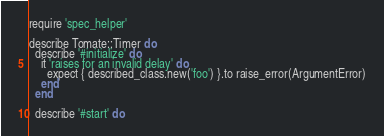Convert code to text. <code><loc_0><loc_0><loc_500><loc_500><_Ruby_>require 'spec_helper'

describe Tomate::Timer do
  describe '#initialize' do
    it 'raises for an invalid delay' do
      expect { described_class.new('foo') }.to raise_error(ArgumentError)
    end
  end

  describe '#start' do</code> 